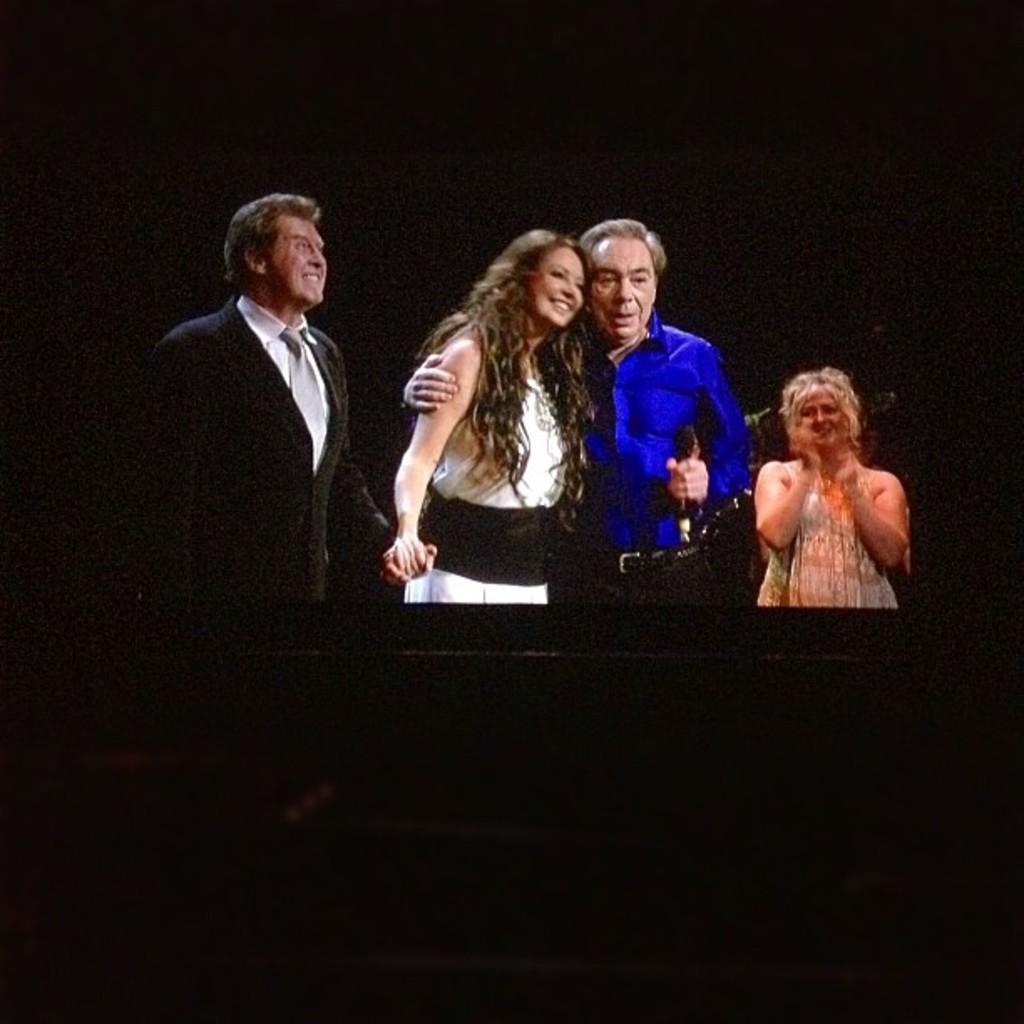Please provide a concise description of this image. There are some people standing. In the background it is dark. 